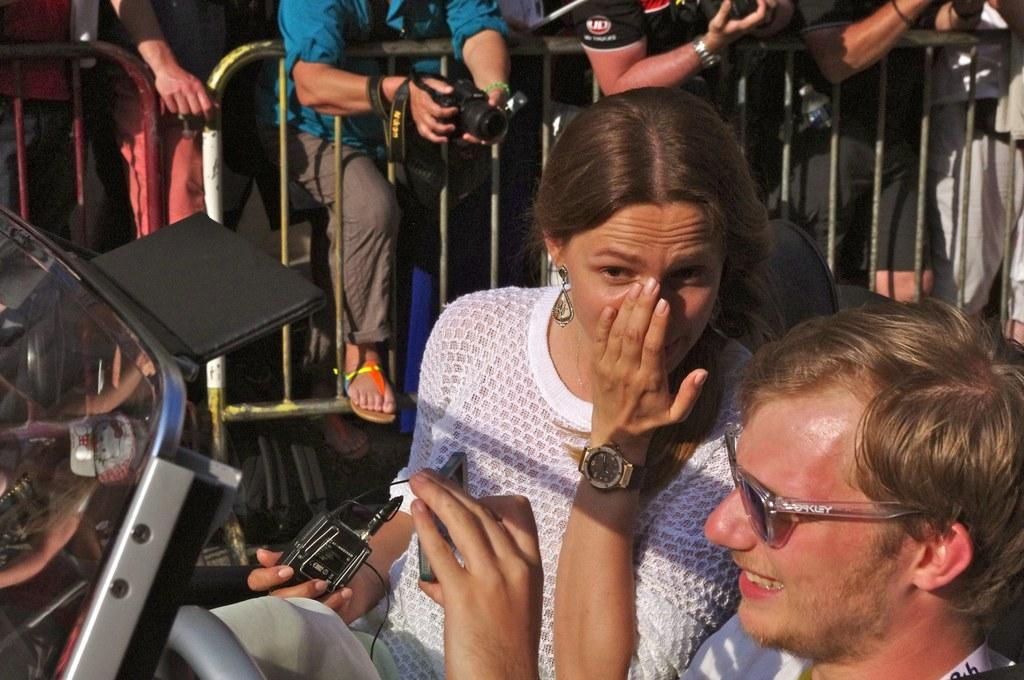How many people are in the image? There are two persons in the image. What is one person holding in the image? One person is holding a mobile. What is the other person holding in the image? The other person is holding an object. What can be seen in the background of the image? There is a fence in the background of the image. Where are the persons standing in the image? The persons are standing on the ground. What type of maid can be seen in the image? There is no maid present in the image. What type of pleasure are the persons experiencing in the image? The image does not depict any specific emotions or experiences, so it cannot be determined if the persons are experiencing pleasure. 